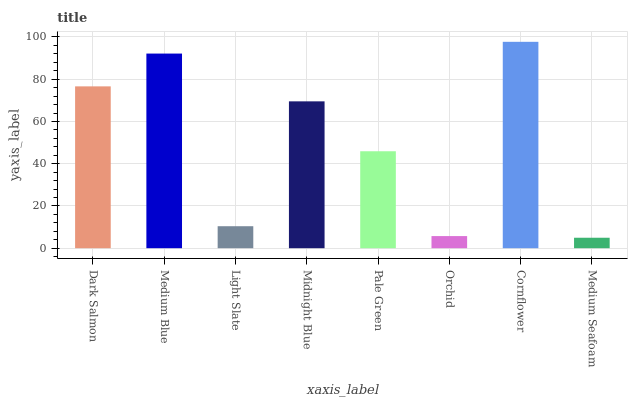Is Medium Seafoam the minimum?
Answer yes or no. Yes. Is Cornflower the maximum?
Answer yes or no. Yes. Is Medium Blue the minimum?
Answer yes or no. No. Is Medium Blue the maximum?
Answer yes or no. No. Is Medium Blue greater than Dark Salmon?
Answer yes or no. Yes. Is Dark Salmon less than Medium Blue?
Answer yes or no. Yes. Is Dark Salmon greater than Medium Blue?
Answer yes or no. No. Is Medium Blue less than Dark Salmon?
Answer yes or no. No. Is Midnight Blue the high median?
Answer yes or no. Yes. Is Pale Green the low median?
Answer yes or no. Yes. Is Cornflower the high median?
Answer yes or no. No. Is Light Slate the low median?
Answer yes or no. No. 